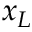<formula> <loc_0><loc_0><loc_500><loc_500>x _ { L }</formula> 